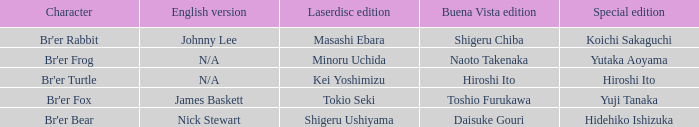Who is the character where the special edition is koichi sakaguchi? Br'er Rabbit. 